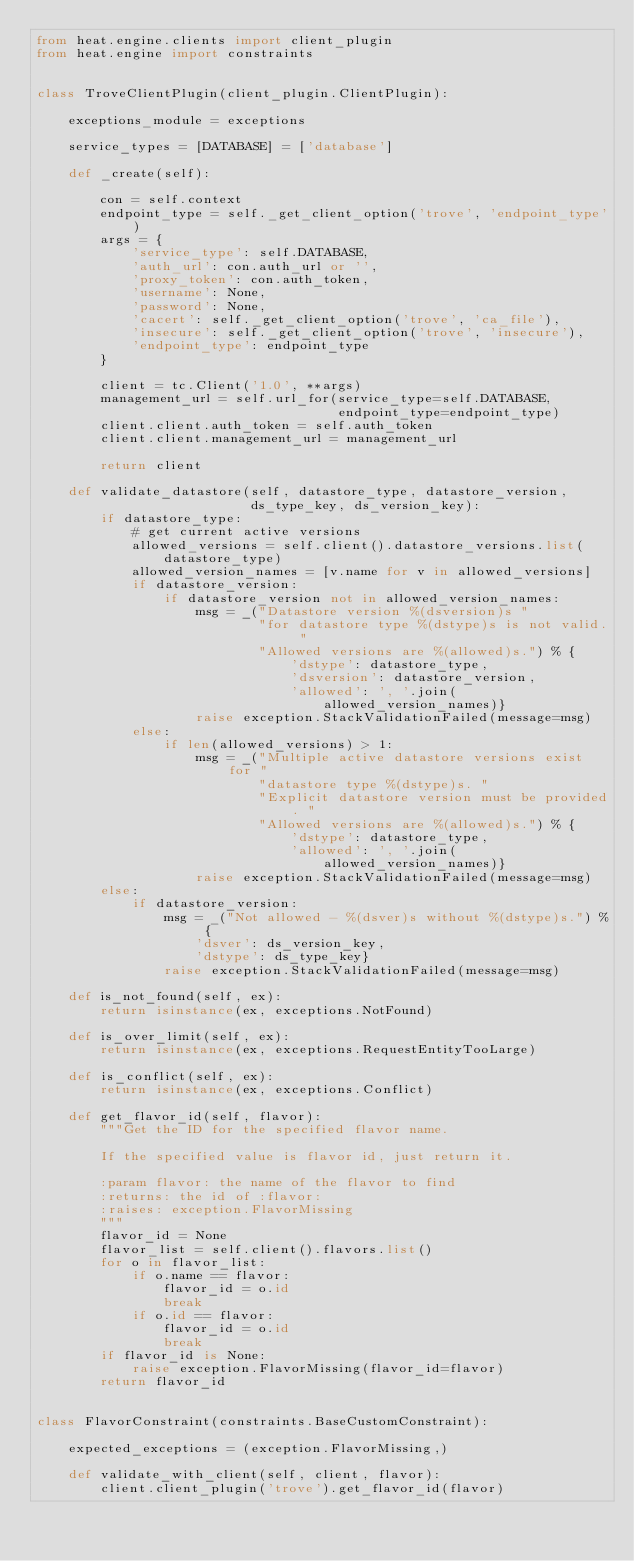Convert code to text. <code><loc_0><loc_0><loc_500><loc_500><_Python_>from heat.engine.clients import client_plugin
from heat.engine import constraints


class TroveClientPlugin(client_plugin.ClientPlugin):

    exceptions_module = exceptions

    service_types = [DATABASE] = ['database']

    def _create(self):

        con = self.context
        endpoint_type = self._get_client_option('trove', 'endpoint_type')
        args = {
            'service_type': self.DATABASE,
            'auth_url': con.auth_url or '',
            'proxy_token': con.auth_token,
            'username': None,
            'password': None,
            'cacert': self._get_client_option('trove', 'ca_file'),
            'insecure': self._get_client_option('trove', 'insecure'),
            'endpoint_type': endpoint_type
        }

        client = tc.Client('1.0', **args)
        management_url = self.url_for(service_type=self.DATABASE,
                                      endpoint_type=endpoint_type)
        client.client.auth_token = self.auth_token
        client.client.management_url = management_url

        return client

    def validate_datastore(self, datastore_type, datastore_version,
                           ds_type_key, ds_version_key):
        if datastore_type:
            # get current active versions
            allowed_versions = self.client().datastore_versions.list(
                datastore_type)
            allowed_version_names = [v.name for v in allowed_versions]
            if datastore_version:
                if datastore_version not in allowed_version_names:
                    msg = _("Datastore version %(dsversion)s "
                            "for datastore type %(dstype)s is not valid. "
                            "Allowed versions are %(allowed)s.") % {
                                'dstype': datastore_type,
                                'dsversion': datastore_version,
                                'allowed': ', '.join(allowed_version_names)}
                    raise exception.StackValidationFailed(message=msg)
            else:
                if len(allowed_versions) > 1:
                    msg = _("Multiple active datastore versions exist for "
                            "datastore type %(dstype)s. "
                            "Explicit datastore version must be provided. "
                            "Allowed versions are %(allowed)s.") % {
                                'dstype': datastore_type,
                                'allowed': ', '.join(allowed_version_names)}
                    raise exception.StackValidationFailed(message=msg)
        else:
            if datastore_version:
                msg = _("Not allowed - %(dsver)s without %(dstype)s.") % {
                    'dsver': ds_version_key,
                    'dstype': ds_type_key}
                raise exception.StackValidationFailed(message=msg)

    def is_not_found(self, ex):
        return isinstance(ex, exceptions.NotFound)

    def is_over_limit(self, ex):
        return isinstance(ex, exceptions.RequestEntityTooLarge)

    def is_conflict(self, ex):
        return isinstance(ex, exceptions.Conflict)

    def get_flavor_id(self, flavor):
        """Get the ID for the specified flavor name.

        If the specified value is flavor id, just return it.

        :param flavor: the name of the flavor to find
        :returns: the id of :flavor:
        :raises: exception.FlavorMissing
        """
        flavor_id = None
        flavor_list = self.client().flavors.list()
        for o in flavor_list:
            if o.name == flavor:
                flavor_id = o.id
                break
            if o.id == flavor:
                flavor_id = o.id
                break
        if flavor_id is None:
            raise exception.FlavorMissing(flavor_id=flavor)
        return flavor_id


class FlavorConstraint(constraints.BaseCustomConstraint):

    expected_exceptions = (exception.FlavorMissing,)

    def validate_with_client(self, client, flavor):
        client.client_plugin('trove').get_flavor_id(flavor)
</code> 